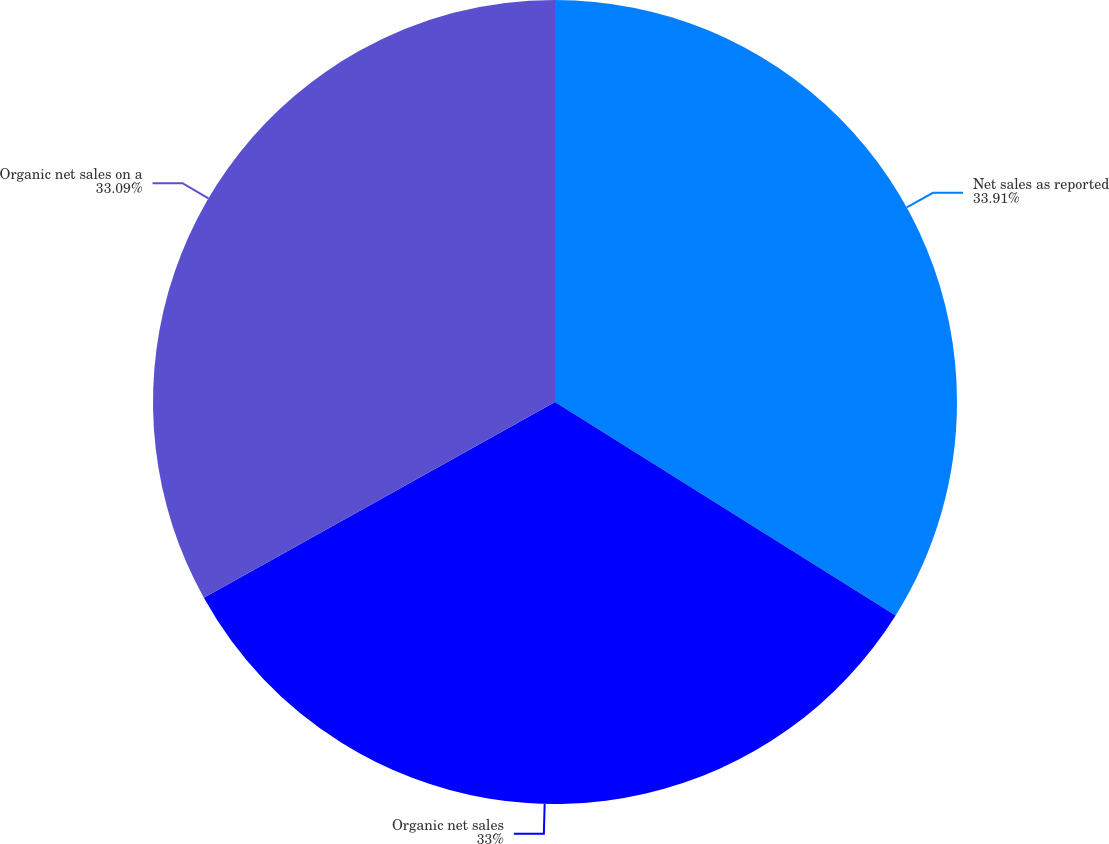Convert chart to OTSL. <chart><loc_0><loc_0><loc_500><loc_500><pie_chart><fcel>Net sales as reported<fcel>Organic net sales<fcel>Organic net sales on a<nl><fcel>33.91%<fcel>33.0%<fcel>33.09%<nl></chart> 